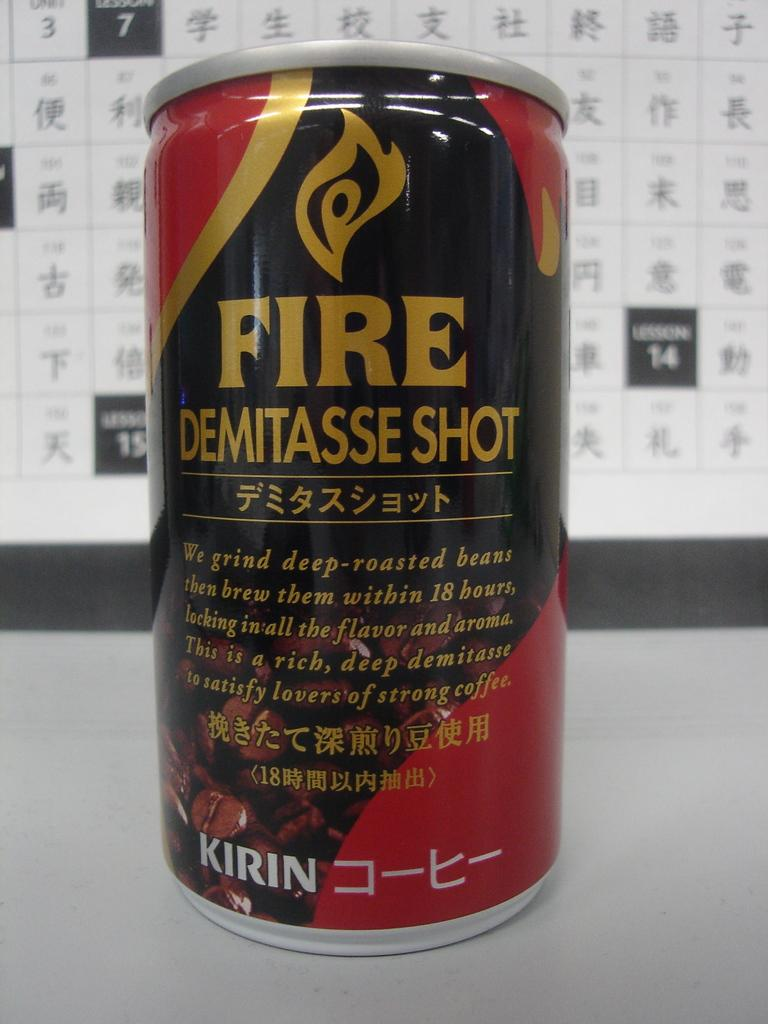Provide a one-sentence caption for the provided image. Can of fire demitasse shot that is kirin. 